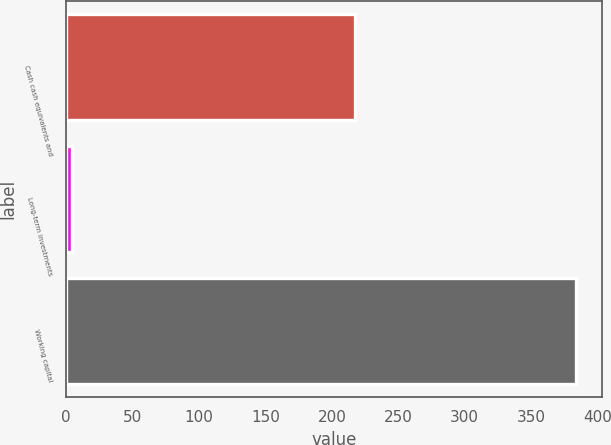Convert chart to OTSL. <chart><loc_0><loc_0><loc_500><loc_500><bar_chart><fcel>Cash cash equivalents and<fcel>Long-term investments<fcel>Working capital<nl><fcel>217<fcel>4<fcel>384<nl></chart> 